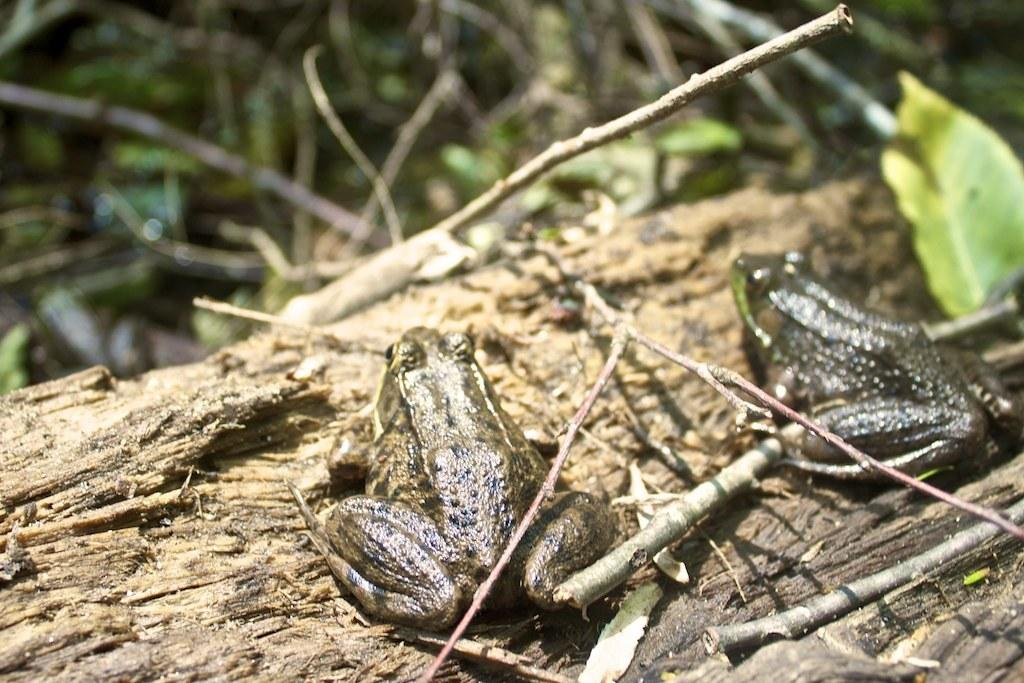What type of animals are present in the image? There are frogs in the image. What type of vegetation can be seen in the image? There are leaves in the image. What can be seen in the background of the image? There are twigs in the background of the image. What material is present at the bottom of the image? There is wood at the bottom of the image. What type of observation can be made about the harmony between the frogs and the skate in the image? There is no skate present in the image, and therefore no observation about harmony can be made. 